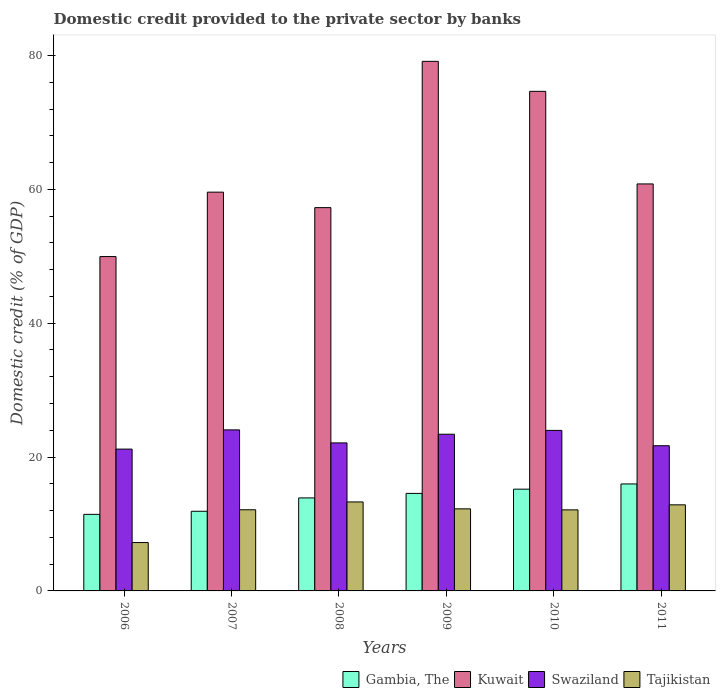How many different coloured bars are there?
Provide a succinct answer. 4. How many groups of bars are there?
Provide a succinct answer. 6. Are the number of bars per tick equal to the number of legend labels?
Provide a short and direct response. Yes. Are the number of bars on each tick of the X-axis equal?
Give a very brief answer. Yes. How many bars are there on the 6th tick from the left?
Provide a succinct answer. 4. How many bars are there on the 1st tick from the right?
Give a very brief answer. 4. What is the domestic credit provided to the private sector by banks in Kuwait in 2006?
Ensure brevity in your answer.  49.95. Across all years, what is the maximum domestic credit provided to the private sector by banks in Kuwait?
Offer a very short reply. 79.12. Across all years, what is the minimum domestic credit provided to the private sector by banks in Kuwait?
Make the answer very short. 49.95. In which year was the domestic credit provided to the private sector by banks in Kuwait maximum?
Your response must be concise. 2009. What is the total domestic credit provided to the private sector by banks in Gambia, The in the graph?
Offer a very short reply. 82.99. What is the difference between the domestic credit provided to the private sector by banks in Swaziland in 2006 and that in 2009?
Your answer should be very brief. -2.22. What is the difference between the domestic credit provided to the private sector by banks in Kuwait in 2007 and the domestic credit provided to the private sector by banks in Tajikistan in 2006?
Make the answer very short. 52.35. What is the average domestic credit provided to the private sector by banks in Kuwait per year?
Your answer should be very brief. 63.56. In the year 2008, what is the difference between the domestic credit provided to the private sector by banks in Gambia, The and domestic credit provided to the private sector by banks in Swaziland?
Give a very brief answer. -8.22. What is the ratio of the domestic credit provided to the private sector by banks in Gambia, The in 2006 to that in 2009?
Provide a succinct answer. 0.79. Is the domestic credit provided to the private sector by banks in Tajikistan in 2008 less than that in 2011?
Your answer should be compact. No. Is the difference between the domestic credit provided to the private sector by banks in Gambia, The in 2006 and 2011 greater than the difference between the domestic credit provided to the private sector by banks in Swaziland in 2006 and 2011?
Your answer should be compact. No. What is the difference between the highest and the second highest domestic credit provided to the private sector by banks in Kuwait?
Ensure brevity in your answer.  4.48. What is the difference between the highest and the lowest domestic credit provided to the private sector by banks in Gambia, The?
Your answer should be compact. 4.54. Is it the case that in every year, the sum of the domestic credit provided to the private sector by banks in Swaziland and domestic credit provided to the private sector by banks in Kuwait is greater than the sum of domestic credit provided to the private sector by banks in Gambia, The and domestic credit provided to the private sector by banks in Tajikistan?
Make the answer very short. Yes. What does the 3rd bar from the left in 2009 represents?
Your answer should be very brief. Swaziland. What does the 4th bar from the right in 2008 represents?
Ensure brevity in your answer.  Gambia, The. Is it the case that in every year, the sum of the domestic credit provided to the private sector by banks in Tajikistan and domestic credit provided to the private sector by banks in Swaziland is greater than the domestic credit provided to the private sector by banks in Kuwait?
Your answer should be very brief. No. Are all the bars in the graph horizontal?
Your answer should be compact. No. What is the difference between two consecutive major ticks on the Y-axis?
Your response must be concise. 20. Does the graph contain grids?
Ensure brevity in your answer.  No. How are the legend labels stacked?
Give a very brief answer. Horizontal. What is the title of the graph?
Provide a succinct answer. Domestic credit provided to the private sector by banks. Does "East Asia (developing only)" appear as one of the legend labels in the graph?
Ensure brevity in your answer.  No. What is the label or title of the Y-axis?
Provide a short and direct response. Domestic credit (% of GDP). What is the Domestic credit (% of GDP) of Gambia, The in 2006?
Your answer should be very brief. 11.44. What is the Domestic credit (% of GDP) of Kuwait in 2006?
Your answer should be very brief. 49.95. What is the Domestic credit (% of GDP) of Swaziland in 2006?
Offer a terse response. 21.19. What is the Domestic credit (% of GDP) in Tajikistan in 2006?
Make the answer very short. 7.23. What is the Domestic credit (% of GDP) of Gambia, The in 2007?
Your response must be concise. 11.9. What is the Domestic credit (% of GDP) of Kuwait in 2007?
Ensure brevity in your answer.  59.58. What is the Domestic credit (% of GDP) in Swaziland in 2007?
Your answer should be very brief. 24.06. What is the Domestic credit (% of GDP) in Tajikistan in 2007?
Keep it short and to the point. 12.13. What is the Domestic credit (% of GDP) in Gambia, The in 2008?
Offer a very short reply. 13.9. What is the Domestic credit (% of GDP) of Kuwait in 2008?
Make the answer very short. 57.26. What is the Domestic credit (% of GDP) of Swaziland in 2008?
Offer a very short reply. 22.11. What is the Domestic credit (% of GDP) in Tajikistan in 2008?
Your answer should be very brief. 13.29. What is the Domestic credit (% of GDP) of Gambia, The in 2009?
Your response must be concise. 14.57. What is the Domestic credit (% of GDP) in Kuwait in 2009?
Give a very brief answer. 79.12. What is the Domestic credit (% of GDP) of Swaziland in 2009?
Your response must be concise. 23.41. What is the Domestic credit (% of GDP) of Tajikistan in 2009?
Offer a very short reply. 12.26. What is the Domestic credit (% of GDP) in Gambia, The in 2010?
Keep it short and to the point. 15.2. What is the Domestic credit (% of GDP) of Kuwait in 2010?
Ensure brevity in your answer.  74.64. What is the Domestic credit (% of GDP) in Swaziland in 2010?
Provide a short and direct response. 23.98. What is the Domestic credit (% of GDP) in Tajikistan in 2010?
Ensure brevity in your answer.  12.11. What is the Domestic credit (% of GDP) in Gambia, The in 2011?
Offer a very short reply. 15.98. What is the Domestic credit (% of GDP) in Kuwait in 2011?
Provide a succinct answer. 60.81. What is the Domestic credit (% of GDP) of Swaziland in 2011?
Your answer should be very brief. 21.69. What is the Domestic credit (% of GDP) in Tajikistan in 2011?
Offer a terse response. 12.86. Across all years, what is the maximum Domestic credit (% of GDP) in Gambia, The?
Keep it short and to the point. 15.98. Across all years, what is the maximum Domestic credit (% of GDP) in Kuwait?
Offer a terse response. 79.12. Across all years, what is the maximum Domestic credit (% of GDP) of Swaziland?
Your response must be concise. 24.06. Across all years, what is the maximum Domestic credit (% of GDP) of Tajikistan?
Keep it short and to the point. 13.29. Across all years, what is the minimum Domestic credit (% of GDP) in Gambia, The?
Make the answer very short. 11.44. Across all years, what is the minimum Domestic credit (% of GDP) of Kuwait?
Your response must be concise. 49.95. Across all years, what is the minimum Domestic credit (% of GDP) in Swaziland?
Keep it short and to the point. 21.19. Across all years, what is the minimum Domestic credit (% of GDP) in Tajikistan?
Your answer should be compact. 7.23. What is the total Domestic credit (% of GDP) of Gambia, The in the graph?
Ensure brevity in your answer.  82.99. What is the total Domestic credit (% of GDP) in Kuwait in the graph?
Give a very brief answer. 381.36. What is the total Domestic credit (% of GDP) in Swaziland in the graph?
Your answer should be compact. 136.45. What is the total Domestic credit (% of GDP) of Tajikistan in the graph?
Keep it short and to the point. 69.88. What is the difference between the Domestic credit (% of GDP) in Gambia, The in 2006 and that in 2007?
Ensure brevity in your answer.  -0.46. What is the difference between the Domestic credit (% of GDP) in Kuwait in 2006 and that in 2007?
Your answer should be very brief. -9.63. What is the difference between the Domestic credit (% of GDP) in Swaziland in 2006 and that in 2007?
Give a very brief answer. -2.87. What is the difference between the Domestic credit (% of GDP) of Tajikistan in 2006 and that in 2007?
Ensure brevity in your answer.  -4.9. What is the difference between the Domestic credit (% of GDP) of Gambia, The in 2006 and that in 2008?
Your answer should be very brief. -2.46. What is the difference between the Domestic credit (% of GDP) in Kuwait in 2006 and that in 2008?
Offer a terse response. -7.31. What is the difference between the Domestic credit (% of GDP) of Swaziland in 2006 and that in 2008?
Offer a terse response. -0.93. What is the difference between the Domestic credit (% of GDP) of Tajikistan in 2006 and that in 2008?
Offer a terse response. -6.07. What is the difference between the Domestic credit (% of GDP) in Gambia, The in 2006 and that in 2009?
Provide a short and direct response. -3.13. What is the difference between the Domestic credit (% of GDP) of Kuwait in 2006 and that in 2009?
Keep it short and to the point. -29.17. What is the difference between the Domestic credit (% of GDP) of Swaziland in 2006 and that in 2009?
Provide a succinct answer. -2.22. What is the difference between the Domestic credit (% of GDP) in Tajikistan in 2006 and that in 2009?
Provide a short and direct response. -5.04. What is the difference between the Domestic credit (% of GDP) in Gambia, The in 2006 and that in 2010?
Give a very brief answer. -3.76. What is the difference between the Domestic credit (% of GDP) of Kuwait in 2006 and that in 2010?
Offer a very short reply. -24.69. What is the difference between the Domestic credit (% of GDP) of Swaziland in 2006 and that in 2010?
Your answer should be compact. -2.79. What is the difference between the Domestic credit (% of GDP) of Tajikistan in 2006 and that in 2010?
Ensure brevity in your answer.  -4.88. What is the difference between the Domestic credit (% of GDP) of Gambia, The in 2006 and that in 2011?
Offer a very short reply. -4.54. What is the difference between the Domestic credit (% of GDP) of Kuwait in 2006 and that in 2011?
Make the answer very short. -10.85. What is the difference between the Domestic credit (% of GDP) of Swaziland in 2006 and that in 2011?
Offer a very short reply. -0.5. What is the difference between the Domestic credit (% of GDP) in Tajikistan in 2006 and that in 2011?
Give a very brief answer. -5.63. What is the difference between the Domestic credit (% of GDP) in Gambia, The in 2007 and that in 2008?
Your answer should be compact. -2. What is the difference between the Domestic credit (% of GDP) of Kuwait in 2007 and that in 2008?
Make the answer very short. 2.31. What is the difference between the Domestic credit (% of GDP) of Swaziland in 2007 and that in 2008?
Offer a very short reply. 1.95. What is the difference between the Domestic credit (% of GDP) of Tajikistan in 2007 and that in 2008?
Your response must be concise. -1.17. What is the difference between the Domestic credit (% of GDP) in Gambia, The in 2007 and that in 2009?
Keep it short and to the point. -2.67. What is the difference between the Domestic credit (% of GDP) in Kuwait in 2007 and that in 2009?
Offer a very short reply. -19.54. What is the difference between the Domestic credit (% of GDP) of Swaziland in 2007 and that in 2009?
Provide a short and direct response. 0.65. What is the difference between the Domestic credit (% of GDP) in Tajikistan in 2007 and that in 2009?
Give a very brief answer. -0.14. What is the difference between the Domestic credit (% of GDP) in Gambia, The in 2007 and that in 2010?
Keep it short and to the point. -3.31. What is the difference between the Domestic credit (% of GDP) in Kuwait in 2007 and that in 2010?
Give a very brief answer. -15.06. What is the difference between the Domestic credit (% of GDP) of Swaziland in 2007 and that in 2010?
Your response must be concise. 0.08. What is the difference between the Domestic credit (% of GDP) in Tajikistan in 2007 and that in 2010?
Provide a succinct answer. 0.02. What is the difference between the Domestic credit (% of GDP) of Gambia, The in 2007 and that in 2011?
Offer a terse response. -4.08. What is the difference between the Domestic credit (% of GDP) of Kuwait in 2007 and that in 2011?
Keep it short and to the point. -1.23. What is the difference between the Domestic credit (% of GDP) of Swaziland in 2007 and that in 2011?
Make the answer very short. 2.37. What is the difference between the Domestic credit (% of GDP) of Tajikistan in 2007 and that in 2011?
Your answer should be compact. -0.73. What is the difference between the Domestic credit (% of GDP) in Gambia, The in 2008 and that in 2009?
Make the answer very short. -0.67. What is the difference between the Domestic credit (% of GDP) of Kuwait in 2008 and that in 2009?
Your response must be concise. -21.85. What is the difference between the Domestic credit (% of GDP) in Swaziland in 2008 and that in 2009?
Your answer should be compact. -1.3. What is the difference between the Domestic credit (% of GDP) of Tajikistan in 2008 and that in 2009?
Your answer should be compact. 1.03. What is the difference between the Domestic credit (% of GDP) in Gambia, The in 2008 and that in 2010?
Your answer should be very brief. -1.31. What is the difference between the Domestic credit (% of GDP) of Kuwait in 2008 and that in 2010?
Your answer should be compact. -17.37. What is the difference between the Domestic credit (% of GDP) in Swaziland in 2008 and that in 2010?
Provide a short and direct response. -1.87. What is the difference between the Domestic credit (% of GDP) in Tajikistan in 2008 and that in 2010?
Your answer should be very brief. 1.18. What is the difference between the Domestic credit (% of GDP) in Gambia, The in 2008 and that in 2011?
Keep it short and to the point. -2.09. What is the difference between the Domestic credit (% of GDP) in Kuwait in 2008 and that in 2011?
Keep it short and to the point. -3.54. What is the difference between the Domestic credit (% of GDP) of Swaziland in 2008 and that in 2011?
Your response must be concise. 0.42. What is the difference between the Domestic credit (% of GDP) in Tajikistan in 2008 and that in 2011?
Make the answer very short. 0.43. What is the difference between the Domestic credit (% of GDP) in Gambia, The in 2009 and that in 2010?
Offer a terse response. -0.63. What is the difference between the Domestic credit (% of GDP) of Kuwait in 2009 and that in 2010?
Provide a short and direct response. 4.48. What is the difference between the Domestic credit (% of GDP) of Swaziland in 2009 and that in 2010?
Offer a very short reply. -0.57. What is the difference between the Domestic credit (% of GDP) of Tajikistan in 2009 and that in 2010?
Make the answer very short. 0.15. What is the difference between the Domestic credit (% of GDP) in Gambia, The in 2009 and that in 2011?
Your answer should be compact. -1.41. What is the difference between the Domestic credit (% of GDP) of Kuwait in 2009 and that in 2011?
Keep it short and to the point. 18.31. What is the difference between the Domestic credit (% of GDP) in Swaziland in 2009 and that in 2011?
Your answer should be compact. 1.72. What is the difference between the Domestic credit (% of GDP) of Tajikistan in 2009 and that in 2011?
Keep it short and to the point. -0.6. What is the difference between the Domestic credit (% of GDP) of Gambia, The in 2010 and that in 2011?
Your answer should be very brief. -0.78. What is the difference between the Domestic credit (% of GDP) of Kuwait in 2010 and that in 2011?
Your answer should be very brief. 13.83. What is the difference between the Domestic credit (% of GDP) of Swaziland in 2010 and that in 2011?
Make the answer very short. 2.29. What is the difference between the Domestic credit (% of GDP) in Tajikistan in 2010 and that in 2011?
Give a very brief answer. -0.75. What is the difference between the Domestic credit (% of GDP) of Gambia, The in 2006 and the Domestic credit (% of GDP) of Kuwait in 2007?
Offer a very short reply. -48.14. What is the difference between the Domestic credit (% of GDP) of Gambia, The in 2006 and the Domestic credit (% of GDP) of Swaziland in 2007?
Your answer should be very brief. -12.62. What is the difference between the Domestic credit (% of GDP) in Gambia, The in 2006 and the Domestic credit (% of GDP) in Tajikistan in 2007?
Keep it short and to the point. -0.69. What is the difference between the Domestic credit (% of GDP) of Kuwait in 2006 and the Domestic credit (% of GDP) of Swaziland in 2007?
Your response must be concise. 25.89. What is the difference between the Domestic credit (% of GDP) of Kuwait in 2006 and the Domestic credit (% of GDP) of Tajikistan in 2007?
Ensure brevity in your answer.  37.83. What is the difference between the Domestic credit (% of GDP) of Swaziland in 2006 and the Domestic credit (% of GDP) of Tajikistan in 2007?
Give a very brief answer. 9.06. What is the difference between the Domestic credit (% of GDP) of Gambia, The in 2006 and the Domestic credit (% of GDP) of Kuwait in 2008?
Offer a very short reply. -45.83. What is the difference between the Domestic credit (% of GDP) of Gambia, The in 2006 and the Domestic credit (% of GDP) of Swaziland in 2008?
Make the answer very short. -10.67. What is the difference between the Domestic credit (% of GDP) of Gambia, The in 2006 and the Domestic credit (% of GDP) of Tajikistan in 2008?
Ensure brevity in your answer.  -1.85. What is the difference between the Domestic credit (% of GDP) in Kuwait in 2006 and the Domestic credit (% of GDP) in Swaziland in 2008?
Provide a succinct answer. 27.84. What is the difference between the Domestic credit (% of GDP) of Kuwait in 2006 and the Domestic credit (% of GDP) of Tajikistan in 2008?
Your response must be concise. 36.66. What is the difference between the Domestic credit (% of GDP) of Swaziland in 2006 and the Domestic credit (% of GDP) of Tajikistan in 2008?
Offer a terse response. 7.9. What is the difference between the Domestic credit (% of GDP) in Gambia, The in 2006 and the Domestic credit (% of GDP) in Kuwait in 2009?
Offer a terse response. -67.68. What is the difference between the Domestic credit (% of GDP) in Gambia, The in 2006 and the Domestic credit (% of GDP) in Swaziland in 2009?
Your answer should be very brief. -11.97. What is the difference between the Domestic credit (% of GDP) of Gambia, The in 2006 and the Domestic credit (% of GDP) of Tajikistan in 2009?
Your answer should be very brief. -0.82. What is the difference between the Domestic credit (% of GDP) in Kuwait in 2006 and the Domestic credit (% of GDP) in Swaziland in 2009?
Provide a succinct answer. 26.54. What is the difference between the Domestic credit (% of GDP) of Kuwait in 2006 and the Domestic credit (% of GDP) of Tajikistan in 2009?
Keep it short and to the point. 37.69. What is the difference between the Domestic credit (% of GDP) of Swaziland in 2006 and the Domestic credit (% of GDP) of Tajikistan in 2009?
Make the answer very short. 8.93. What is the difference between the Domestic credit (% of GDP) of Gambia, The in 2006 and the Domestic credit (% of GDP) of Kuwait in 2010?
Provide a succinct answer. -63.2. What is the difference between the Domestic credit (% of GDP) of Gambia, The in 2006 and the Domestic credit (% of GDP) of Swaziland in 2010?
Provide a succinct answer. -12.54. What is the difference between the Domestic credit (% of GDP) of Gambia, The in 2006 and the Domestic credit (% of GDP) of Tajikistan in 2010?
Your answer should be compact. -0.67. What is the difference between the Domestic credit (% of GDP) of Kuwait in 2006 and the Domestic credit (% of GDP) of Swaziland in 2010?
Your answer should be very brief. 25.97. What is the difference between the Domestic credit (% of GDP) of Kuwait in 2006 and the Domestic credit (% of GDP) of Tajikistan in 2010?
Give a very brief answer. 37.84. What is the difference between the Domestic credit (% of GDP) in Swaziland in 2006 and the Domestic credit (% of GDP) in Tajikistan in 2010?
Your answer should be very brief. 9.08. What is the difference between the Domestic credit (% of GDP) in Gambia, The in 2006 and the Domestic credit (% of GDP) in Kuwait in 2011?
Your answer should be very brief. -49.37. What is the difference between the Domestic credit (% of GDP) in Gambia, The in 2006 and the Domestic credit (% of GDP) in Swaziland in 2011?
Make the answer very short. -10.25. What is the difference between the Domestic credit (% of GDP) of Gambia, The in 2006 and the Domestic credit (% of GDP) of Tajikistan in 2011?
Give a very brief answer. -1.42. What is the difference between the Domestic credit (% of GDP) of Kuwait in 2006 and the Domestic credit (% of GDP) of Swaziland in 2011?
Keep it short and to the point. 28.26. What is the difference between the Domestic credit (% of GDP) of Kuwait in 2006 and the Domestic credit (% of GDP) of Tajikistan in 2011?
Offer a very short reply. 37.09. What is the difference between the Domestic credit (% of GDP) in Swaziland in 2006 and the Domestic credit (% of GDP) in Tajikistan in 2011?
Keep it short and to the point. 8.33. What is the difference between the Domestic credit (% of GDP) in Gambia, The in 2007 and the Domestic credit (% of GDP) in Kuwait in 2008?
Your response must be concise. -45.37. What is the difference between the Domestic credit (% of GDP) of Gambia, The in 2007 and the Domestic credit (% of GDP) of Swaziland in 2008?
Give a very brief answer. -10.22. What is the difference between the Domestic credit (% of GDP) in Gambia, The in 2007 and the Domestic credit (% of GDP) in Tajikistan in 2008?
Provide a succinct answer. -1.39. What is the difference between the Domestic credit (% of GDP) of Kuwait in 2007 and the Domestic credit (% of GDP) of Swaziland in 2008?
Give a very brief answer. 37.46. What is the difference between the Domestic credit (% of GDP) of Kuwait in 2007 and the Domestic credit (% of GDP) of Tajikistan in 2008?
Offer a very short reply. 46.29. What is the difference between the Domestic credit (% of GDP) in Swaziland in 2007 and the Domestic credit (% of GDP) in Tajikistan in 2008?
Make the answer very short. 10.77. What is the difference between the Domestic credit (% of GDP) of Gambia, The in 2007 and the Domestic credit (% of GDP) of Kuwait in 2009?
Your answer should be very brief. -67.22. What is the difference between the Domestic credit (% of GDP) in Gambia, The in 2007 and the Domestic credit (% of GDP) in Swaziland in 2009?
Provide a short and direct response. -11.51. What is the difference between the Domestic credit (% of GDP) in Gambia, The in 2007 and the Domestic credit (% of GDP) in Tajikistan in 2009?
Keep it short and to the point. -0.36. What is the difference between the Domestic credit (% of GDP) of Kuwait in 2007 and the Domestic credit (% of GDP) of Swaziland in 2009?
Ensure brevity in your answer.  36.17. What is the difference between the Domestic credit (% of GDP) of Kuwait in 2007 and the Domestic credit (% of GDP) of Tajikistan in 2009?
Ensure brevity in your answer.  47.32. What is the difference between the Domestic credit (% of GDP) in Swaziland in 2007 and the Domestic credit (% of GDP) in Tajikistan in 2009?
Make the answer very short. 11.8. What is the difference between the Domestic credit (% of GDP) in Gambia, The in 2007 and the Domestic credit (% of GDP) in Kuwait in 2010?
Offer a very short reply. -62.74. What is the difference between the Domestic credit (% of GDP) in Gambia, The in 2007 and the Domestic credit (% of GDP) in Swaziland in 2010?
Provide a succinct answer. -12.08. What is the difference between the Domestic credit (% of GDP) of Gambia, The in 2007 and the Domestic credit (% of GDP) of Tajikistan in 2010?
Offer a terse response. -0.21. What is the difference between the Domestic credit (% of GDP) in Kuwait in 2007 and the Domestic credit (% of GDP) in Swaziland in 2010?
Offer a terse response. 35.6. What is the difference between the Domestic credit (% of GDP) of Kuwait in 2007 and the Domestic credit (% of GDP) of Tajikistan in 2010?
Provide a succinct answer. 47.47. What is the difference between the Domestic credit (% of GDP) in Swaziland in 2007 and the Domestic credit (% of GDP) in Tajikistan in 2010?
Offer a terse response. 11.95. What is the difference between the Domestic credit (% of GDP) in Gambia, The in 2007 and the Domestic credit (% of GDP) in Kuwait in 2011?
Ensure brevity in your answer.  -48.91. What is the difference between the Domestic credit (% of GDP) of Gambia, The in 2007 and the Domestic credit (% of GDP) of Swaziland in 2011?
Your response must be concise. -9.79. What is the difference between the Domestic credit (% of GDP) of Gambia, The in 2007 and the Domestic credit (% of GDP) of Tajikistan in 2011?
Your answer should be very brief. -0.96. What is the difference between the Domestic credit (% of GDP) in Kuwait in 2007 and the Domestic credit (% of GDP) in Swaziland in 2011?
Make the answer very short. 37.89. What is the difference between the Domestic credit (% of GDP) in Kuwait in 2007 and the Domestic credit (% of GDP) in Tajikistan in 2011?
Offer a very short reply. 46.72. What is the difference between the Domestic credit (% of GDP) of Swaziland in 2007 and the Domestic credit (% of GDP) of Tajikistan in 2011?
Ensure brevity in your answer.  11.2. What is the difference between the Domestic credit (% of GDP) in Gambia, The in 2008 and the Domestic credit (% of GDP) in Kuwait in 2009?
Provide a succinct answer. -65.22. What is the difference between the Domestic credit (% of GDP) of Gambia, The in 2008 and the Domestic credit (% of GDP) of Swaziland in 2009?
Provide a succinct answer. -9.51. What is the difference between the Domestic credit (% of GDP) in Gambia, The in 2008 and the Domestic credit (% of GDP) in Tajikistan in 2009?
Offer a terse response. 1.63. What is the difference between the Domestic credit (% of GDP) in Kuwait in 2008 and the Domestic credit (% of GDP) in Swaziland in 2009?
Give a very brief answer. 33.85. What is the difference between the Domestic credit (% of GDP) in Kuwait in 2008 and the Domestic credit (% of GDP) in Tajikistan in 2009?
Offer a terse response. 45. What is the difference between the Domestic credit (% of GDP) in Swaziland in 2008 and the Domestic credit (% of GDP) in Tajikistan in 2009?
Offer a very short reply. 9.85. What is the difference between the Domestic credit (% of GDP) in Gambia, The in 2008 and the Domestic credit (% of GDP) in Kuwait in 2010?
Offer a very short reply. -60.74. What is the difference between the Domestic credit (% of GDP) in Gambia, The in 2008 and the Domestic credit (% of GDP) in Swaziland in 2010?
Keep it short and to the point. -10.09. What is the difference between the Domestic credit (% of GDP) in Gambia, The in 2008 and the Domestic credit (% of GDP) in Tajikistan in 2010?
Your answer should be compact. 1.79. What is the difference between the Domestic credit (% of GDP) of Kuwait in 2008 and the Domestic credit (% of GDP) of Swaziland in 2010?
Offer a very short reply. 33.28. What is the difference between the Domestic credit (% of GDP) of Kuwait in 2008 and the Domestic credit (% of GDP) of Tajikistan in 2010?
Your answer should be compact. 45.15. What is the difference between the Domestic credit (% of GDP) of Swaziland in 2008 and the Domestic credit (% of GDP) of Tajikistan in 2010?
Keep it short and to the point. 10. What is the difference between the Domestic credit (% of GDP) in Gambia, The in 2008 and the Domestic credit (% of GDP) in Kuwait in 2011?
Your answer should be compact. -46.91. What is the difference between the Domestic credit (% of GDP) in Gambia, The in 2008 and the Domestic credit (% of GDP) in Swaziland in 2011?
Offer a terse response. -7.8. What is the difference between the Domestic credit (% of GDP) of Gambia, The in 2008 and the Domestic credit (% of GDP) of Tajikistan in 2011?
Ensure brevity in your answer.  1.04. What is the difference between the Domestic credit (% of GDP) in Kuwait in 2008 and the Domestic credit (% of GDP) in Swaziland in 2011?
Your response must be concise. 35.57. What is the difference between the Domestic credit (% of GDP) of Kuwait in 2008 and the Domestic credit (% of GDP) of Tajikistan in 2011?
Your answer should be compact. 44.4. What is the difference between the Domestic credit (% of GDP) in Swaziland in 2008 and the Domestic credit (% of GDP) in Tajikistan in 2011?
Ensure brevity in your answer.  9.25. What is the difference between the Domestic credit (% of GDP) in Gambia, The in 2009 and the Domestic credit (% of GDP) in Kuwait in 2010?
Offer a terse response. -60.07. What is the difference between the Domestic credit (% of GDP) of Gambia, The in 2009 and the Domestic credit (% of GDP) of Swaziland in 2010?
Give a very brief answer. -9.41. What is the difference between the Domestic credit (% of GDP) in Gambia, The in 2009 and the Domestic credit (% of GDP) in Tajikistan in 2010?
Your answer should be very brief. 2.46. What is the difference between the Domestic credit (% of GDP) of Kuwait in 2009 and the Domestic credit (% of GDP) of Swaziland in 2010?
Ensure brevity in your answer.  55.14. What is the difference between the Domestic credit (% of GDP) of Kuwait in 2009 and the Domestic credit (% of GDP) of Tajikistan in 2010?
Offer a terse response. 67.01. What is the difference between the Domestic credit (% of GDP) of Swaziland in 2009 and the Domestic credit (% of GDP) of Tajikistan in 2010?
Give a very brief answer. 11.3. What is the difference between the Domestic credit (% of GDP) of Gambia, The in 2009 and the Domestic credit (% of GDP) of Kuwait in 2011?
Provide a succinct answer. -46.24. What is the difference between the Domestic credit (% of GDP) in Gambia, The in 2009 and the Domestic credit (% of GDP) in Swaziland in 2011?
Make the answer very short. -7.12. What is the difference between the Domestic credit (% of GDP) in Gambia, The in 2009 and the Domestic credit (% of GDP) in Tajikistan in 2011?
Your answer should be compact. 1.71. What is the difference between the Domestic credit (% of GDP) of Kuwait in 2009 and the Domestic credit (% of GDP) of Swaziland in 2011?
Give a very brief answer. 57.43. What is the difference between the Domestic credit (% of GDP) of Kuwait in 2009 and the Domestic credit (% of GDP) of Tajikistan in 2011?
Offer a terse response. 66.26. What is the difference between the Domestic credit (% of GDP) in Swaziland in 2009 and the Domestic credit (% of GDP) in Tajikistan in 2011?
Keep it short and to the point. 10.55. What is the difference between the Domestic credit (% of GDP) in Gambia, The in 2010 and the Domestic credit (% of GDP) in Kuwait in 2011?
Keep it short and to the point. -45.6. What is the difference between the Domestic credit (% of GDP) of Gambia, The in 2010 and the Domestic credit (% of GDP) of Swaziland in 2011?
Ensure brevity in your answer.  -6.49. What is the difference between the Domestic credit (% of GDP) of Gambia, The in 2010 and the Domestic credit (% of GDP) of Tajikistan in 2011?
Ensure brevity in your answer.  2.34. What is the difference between the Domestic credit (% of GDP) in Kuwait in 2010 and the Domestic credit (% of GDP) in Swaziland in 2011?
Your response must be concise. 52.95. What is the difference between the Domestic credit (% of GDP) of Kuwait in 2010 and the Domestic credit (% of GDP) of Tajikistan in 2011?
Your answer should be compact. 61.78. What is the difference between the Domestic credit (% of GDP) of Swaziland in 2010 and the Domestic credit (% of GDP) of Tajikistan in 2011?
Provide a short and direct response. 11.12. What is the average Domestic credit (% of GDP) in Gambia, The per year?
Make the answer very short. 13.83. What is the average Domestic credit (% of GDP) of Kuwait per year?
Provide a succinct answer. 63.56. What is the average Domestic credit (% of GDP) in Swaziland per year?
Your response must be concise. 22.74. What is the average Domestic credit (% of GDP) in Tajikistan per year?
Give a very brief answer. 11.65. In the year 2006, what is the difference between the Domestic credit (% of GDP) in Gambia, The and Domestic credit (% of GDP) in Kuwait?
Ensure brevity in your answer.  -38.51. In the year 2006, what is the difference between the Domestic credit (% of GDP) in Gambia, The and Domestic credit (% of GDP) in Swaziland?
Provide a short and direct response. -9.75. In the year 2006, what is the difference between the Domestic credit (% of GDP) in Gambia, The and Domestic credit (% of GDP) in Tajikistan?
Offer a very short reply. 4.21. In the year 2006, what is the difference between the Domestic credit (% of GDP) of Kuwait and Domestic credit (% of GDP) of Swaziland?
Your answer should be compact. 28.76. In the year 2006, what is the difference between the Domestic credit (% of GDP) of Kuwait and Domestic credit (% of GDP) of Tajikistan?
Offer a terse response. 42.73. In the year 2006, what is the difference between the Domestic credit (% of GDP) in Swaziland and Domestic credit (% of GDP) in Tajikistan?
Offer a terse response. 13.96. In the year 2007, what is the difference between the Domestic credit (% of GDP) in Gambia, The and Domestic credit (% of GDP) in Kuwait?
Give a very brief answer. -47.68. In the year 2007, what is the difference between the Domestic credit (% of GDP) of Gambia, The and Domestic credit (% of GDP) of Swaziland?
Give a very brief answer. -12.16. In the year 2007, what is the difference between the Domestic credit (% of GDP) of Gambia, The and Domestic credit (% of GDP) of Tajikistan?
Provide a succinct answer. -0.23. In the year 2007, what is the difference between the Domestic credit (% of GDP) of Kuwait and Domestic credit (% of GDP) of Swaziland?
Your answer should be compact. 35.52. In the year 2007, what is the difference between the Domestic credit (% of GDP) of Kuwait and Domestic credit (% of GDP) of Tajikistan?
Ensure brevity in your answer.  47.45. In the year 2007, what is the difference between the Domestic credit (% of GDP) of Swaziland and Domestic credit (% of GDP) of Tajikistan?
Your answer should be very brief. 11.93. In the year 2008, what is the difference between the Domestic credit (% of GDP) of Gambia, The and Domestic credit (% of GDP) of Kuwait?
Give a very brief answer. -43.37. In the year 2008, what is the difference between the Domestic credit (% of GDP) of Gambia, The and Domestic credit (% of GDP) of Swaziland?
Keep it short and to the point. -8.22. In the year 2008, what is the difference between the Domestic credit (% of GDP) of Gambia, The and Domestic credit (% of GDP) of Tajikistan?
Your response must be concise. 0.6. In the year 2008, what is the difference between the Domestic credit (% of GDP) in Kuwait and Domestic credit (% of GDP) in Swaziland?
Your answer should be compact. 35.15. In the year 2008, what is the difference between the Domestic credit (% of GDP) in Kuwait and Domestic credit (% of GDP) in Tajikistan?
Your answer should be compact. 43.97. In the year 2008, what is the difference between the Domestic credit (% of GDP) of Swaziland and Domestic credit (% of GDP) of Tajikistan?
Offer a terse response. 8.82. In the year 2009, what is the difference between the Domestic credit (% of GDP) of Gambia, The and Domestic credit (% of GDP) of Kuwait?
Keep it short and to the point. -64.55. In the year 2009, what is the difference between the Domestic credit (% of GDP) in Gambia, The and Domestic credit (% of GDP) in Swaziland?
Your answer should be compact. -8.84. In the year 2009, what is the difference between the Domestic credit (% of GDP) in Gambia, The and Domestic credit (% of GDP) in Tajikistan?
Your response must be concise. 2.31. In the year 2009, what is the difference between the Domestic credit (% of GDP) of Kuwait and Domestic credit (% of GDP) of Swaziland?
Provide a short and direct response. 55.71. In the year 2009, what is the difference between the Domestic credit (% of GDP) in Kuwait and Domestic credit (% of GDP) in Tajikistan?
Make the answer very short. 66.86. In the year 2009, what is the difference between the Domestic credit (% of GDP) in Swaziland and Domestic credit (% of GDP) in Tajikistan?
Make the answer very short. 11.15. In the year 2010, what is the difference between the Domestic credit (% of GDP) of Gambia, The and Domestic credit (% of GDP) of Kuwait?
Ensure brevity in your answer.  -59.44. In the year 2010, what is the difference between the Domestic credit (% of GDP) in Gambia, The and Domestic credit (% of GDP) in Swaziland?
Your answer should be very brief. -8.78. In the year 2010, what is the difference between the Domestic credit (% of GDP) of Gambia, The and Domestic credit (% of GDP) of Tajikistan?
Ensure brevity in your answer.  3.09. In the year 2010, what is the difference between the Domestic credit (% of GDP) of Kuwait and Domestic credit (% of GDP) of Swaziland?
Provide a short and direct response. 50.66. In the year 2010, what is the difference between the Domestic credit (% of GDP) of Kuwait and Domestic credit (% of GDP) of Tajikistan?
Your response must be concise. 62.53. In the year 2010, what is the difference between the Domestic credit (% of GDP) of Swaziland and Domestic credit (% of GDP) of Tajikistan?
Make the answer very short. 11.87. In the year 2011, what is the difference between the Domestic credit (% of GDP) of Gambia, The and Domestic credit (% of GDP) of Kuwait?
Ensure brevity in your answer.  -44.82. In the year 2011, what is the difference between the Domestic credit (% of GDP) in Gambia, The and Domestic credit (% of GDP) in Swaziland?
Make the answer very short. -5.71. In the year 2011, what is the difference between the Domestic credit (% of GDP) of Gambia, The and Domestic credit (% of GDP) of Tajikistan?
Provide a succinct answer. 3.12. In the year 2011, what is the difference between the Domestic credit (% of GDP) in Kuwait and Domestic credit (% of GDP) in Swaziland?
Your answer should be very brief. 39.11. In the year 2011, what is the difference between the Domestic credit (% of GDP) in Kuwait and Domestic credit (% of GDP) in Tajikistan?
Ensure brevity in your answer.  47.95. In the year 2011, what is the difference between the Domestic credit (% of GDP) in Swaziland and Domestic credit (% of GDP) in Tajikistan?
Provide a succinct answer. 8.83. What is the ratio of the Domestic credit (% of GDP) in Gambia, The in 2006 to that in 2007?
Offer a terse response. 0.96. What is the ratio of the Domestic credit (% of GDP) in Kuwait in 2006 to that in 2007?
Ensure brevity in your answer.  0.84. What is the ratio of the Domestic credit (% of GDP) of Swaziland in 2006 to that in 2007?
Your answer should be compact. 0.88. What is the ratio of the Domestic credit (% of GDP) of Tajikistan in 2006 to that in 2007?
Give a very brief answer. 0.6. What is the ratio of the Domestic credit (% of GDP) in Gambia, The in 2006 to that in 2008?
Offer a terse response. 0.82. What is the ratio of the Domestic credit (% of GDP) of Kuwait in 2006 to that in 2008?
Provide a short and direct response. 0.87. What is the ratio of the Domestic credit (% of GDP) of Swaziland in 2006 to that in 2008?
Ensure brevity in your answer.  0.96. What is the ratio of the Domestic credit (% of GDP) in Tajikistan in 2006 to that in 2008?
Provide a succinct answer. 0.54. What is the ratio of the Domestic credit (% of GDP) in Gambia, The in 2006 to that in 2009?
Your answer should be very brief. 0.79. What is the ratio of the Domestic credit (% of GDP) in Kuwait in 2006 to that in 2009?
Your answer should be compact. 0.63. What is the ratio of the Domestic credit (% of GDP) in Swaziland in 2006 to that in 2009?
Ensure brevity in your answer.  0.91. What is the ratio of the Domestic credit (% of GDP) in Tajikistan in 2006 to that in 2009?
Make the answer very short. 0.59. What is the ratio of the Domestic credit (% of GDP) in Gambia, The in 2006 to that in 2010?
Your answer should be very brief. 0.75. What is the ratio of the Domestic credit (% of GDP) in Kuwait in 2006 to that in 2010?
Provide a succinct answer. 0.67. What is the ratio of the Domestic credit (% of GDP) of Swaziland in 2006 to that in 2010?
Provide a short and direct response. 0.88. What is the ratio of the Domestic credit (% of GDP) in Tajikistan in 2006 to that in 2010?
Offer a terse response. 0.6. What is the ratio of the Domestic credit (% of GDP) in Gambia, The in 2006 to that in 2011?
Give a very brief answer. 0.72. What is the ratio of the Domestic credit (% of GDP) in Kuwait in 2006 to that in 2011?
Make the answer very short. 0.82. What is the ratio of the Domestic credit (% of GDP) of Swaziland in 2006 to that in 2011?
Provide a succinct answer. 0.98. What is the ratio of the Domestic credit (% of GDP) in Tajikistan in 2006 to that in 2011?
Offer a terse response. 0.56. What is the ratio of the Domestic credit (% of GDP) in Gambia, The in 2007 to that in 2008?
Your answer should be compact. 0.86. What is the ratio of the Domestic credit (% of GDP) of Kuwait in 2007 to that in 2008?
Provide a short and direct response. 1.04. What is the ratio of the Domestic credit (% of GDP) of Swaziland in 2007 to that in 2008?
Make the answer very short. 1.09. What is the ratio of the Domestic credit (% of GDP) in Tajikistan in 2007 to that in 2008?
Give a very brief answer. 0.91. What is the ratio of the Domestic credit (% of GDP) of Gambia, The in 2007 to that in 2009?
Offer a very short reply. 0.82. What is the ratio of the Domestic credit (% of GDP) in Kuwait in 2007 to that in 2009?
Provide a short and direct response. 0.75. What is the ratio of the Domestic credit (% of GDP) in Swaziland in 2007 to that in 2009?
Make the answer very short. 1.03. What is the ratio of the Domestic credit (% of GDP) in Gambia, The in 2007 to that in 2010?
Provide a succinct answer. 0.78. What is the ratio of the Domestic credit (% of GDP) of Kuwait in 2007 to that in 2010?
Keep it short and to the point. 0.8. What is the ratio of the Domestic credit (% of GDP) of Gambia, The in 2007 to that in 2011?
Ensure brevity in your answer.  0.74. What is the ratio of the Domestic credit (% of GDP) in Kuwait in 2007 to that in 2011?
Your answer should be compact. 0.98. What is the ratio of the Domestic credit (% of GDP) of Swaziland in 2007 to that in 2011?
Ensure brevity in your answer.  1.11. What is the ratio of the Domestic credit (% of GDP) in Tajikistan in 2007 to that in 2011?
Offer a very short reply. 0.94. What is the ratio of the Domestic credit (% of GDP) of Gambia, The in 2008 to that in 2009?
Your response must be concise. 0.95. What is the ratio of the Domestic credit (% of GDP) of Kuwait in 2008 to that in 2009?
Keep it short and to the point. 0.72. What is the ratio of the Domestic credit (% of GDP) of Swaziland in 2008 to that in 2009?
Provide a short and direct response. 0.94. What is the ratio of the Domestic credit (% of GDP) of Tajikistan in 2008 to that in 2009?
Provide a short and direct response. 1.08. What is the ratio of the Domestic credit (% of GDP) in Gambia, The in 2008 to that in 2010?
Your answer should be compact. 0.91. What is the ratio of the Domestic credit (% of GDP) in Kuwait in 2008 to that in 2010?
Provide a succinct answer. 0.77. What is the ratio of the Domestic credit (% of GDP) in Swaziland in 2008 to that in 2010?
Offer a very short reply. 0.92. What is the ratio of the Domestic credit (% of GDP) in Tajikistan in 2008 to that in 2010?
Your answer should be very brief. 1.1. What is the ratio of the Domestic credit (% of GDP) in Gambia, The in 2008 to that in 2011?
Your answer should be compact. 0.87. What is the ratio of the Domestic credit (% of GDP) in Kuwait in 2008 to that in 2011?
Make the answer very short. 0.94. What is the ratio of the Domestic credit (% of GDP) in Swaziland in 2008 to that in 2011?
Your response must be concise. 1.02. What is the ratio of the Domestic credit (% of GDP) of Tajikistan in 2008 to that in 2011?
Give a very brief answer. 1.03. What is the ratio of the Domestic credit (% of GDP) of Gambia, The in 2009 to that in 2010?
Offer a very short reply. 0.96. What is the ratio of the Domestic credit (% of GDP) of Kuwait in 2009 to that in 2010?
Make the answer very short. 1.06. What is the ratio of the Domestic credit (% of GDP) of Swaziland in 2009 to that in 2010?
Provide a succinct answer. 0.98. What is the ratio of the Domestic credit (% of GDP) of Tajikistan in 2009 to that in 2010?
Your answer should be very brief. 1.01. What is the ratio of the Domestic credit (% of GDP) of Gambia, The in 2009 to that in 2011?
Keep it short and to the point. 0.91. What is the ratio of the Domestic credit (% of GDP) in Kuwait in 2009 to that in 2011?
Your response must be concise. 1.3. What is the ratio of the Domestic credit (% of GDP) of Swaziland in 2009 to that in 2011?
Your response must be concise. 1.08. What is the ratio of the Domestic credit (% of GDP) in Tajikistan in 2009 to that in 2011?
Keep it short and to the point. 0.95. What is the ratio of the Domestic credit (% of GDP) in Gambia, The in 2010 to that in 2011?
Keep it short and to the point. 0.95. What is the ratio of the Domestic credit (% of GDP) of Kuwait in 2010 to that in 2011?
Keep it short and to the point. 1.23. What is the ratio of the Domestic credit (% of GDP) in Swaziland in 2010 to that in 2011?
Make the answer very short. 1.11. What is the ratio of the Domestic credit (% of GDP) in Tajikistan in 2010 to that in 2011?
Offer a terse response. 0.94. What is the difference between the highest and the second highest Domestic credit (% of GDP) in Gambia, The?
Ensure brevity in your answer.  0.78. What is the difference between the highest and the second highest Domestic credit (% of GDP) of Kuwait?
Offer a terse response. 4.48. What is the difference between the highest and the second highest Domestic credit (% of GDP) of Swaziland?
Ensure brevity in your answer.  0.08. What is the difference between the highest and the second highest Domestic credit (% of GDP) of Tajikistan?
Provide a short and direct response. 0.43. What is the difference between the highest and the lowest Domestic credit (% of GDP) of Gambia, The?
Give a very brief answer. 4.54. What is the difference between the highest and the lowest Domestic credit (% of GDP) of Kuwait?
Provide a succinct answer. 29.17. What is the difference between the highest and the lowest Domestic credit (% of GDP) of Swaziland?
Provide a succinct answer. 2.87. What is the difference between the highest and the lowest Domestic credit (% of GDP) in Tajikistan?
Ensure brevity in your answer.  6.07. 